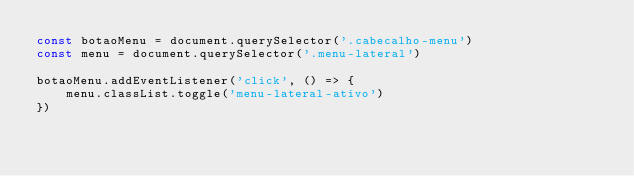Convert code to text. <code><loc_0><loc_0><loc_500><loc_500><_JavaScript_>const botaoMenu = document.querySelector('.cabecalho-menu')
const menu = document.querySelector('.menu-lateral')

botaoMenu.addEventListener('click', () => {
    menu.classList.toggle('menu-lateral-ativo')
})</code> 